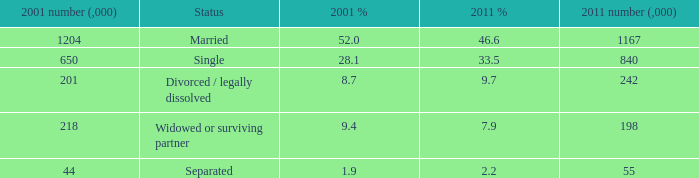Give me the full table as a dictionary. {'header': ['2001 number (,000)', 'Status', '2001 %', '2011 %', '2011 number (,000)'], 'rows': [['1204', 'Married', '52.0', '46.6', '1167'], ['650', 'Single', '28.1', '33.5', '840'], ['201', 'Divorced / legally dissolved', '8.7', '9.7', '242'], ['218', 'Widowed or surviving partner', '9.4', '7.9', '198'], ['44', 'Separated', '1.9', '2.2', '55']]} What is the 2001 % for the status widowed or surviving partner? 9.4. 